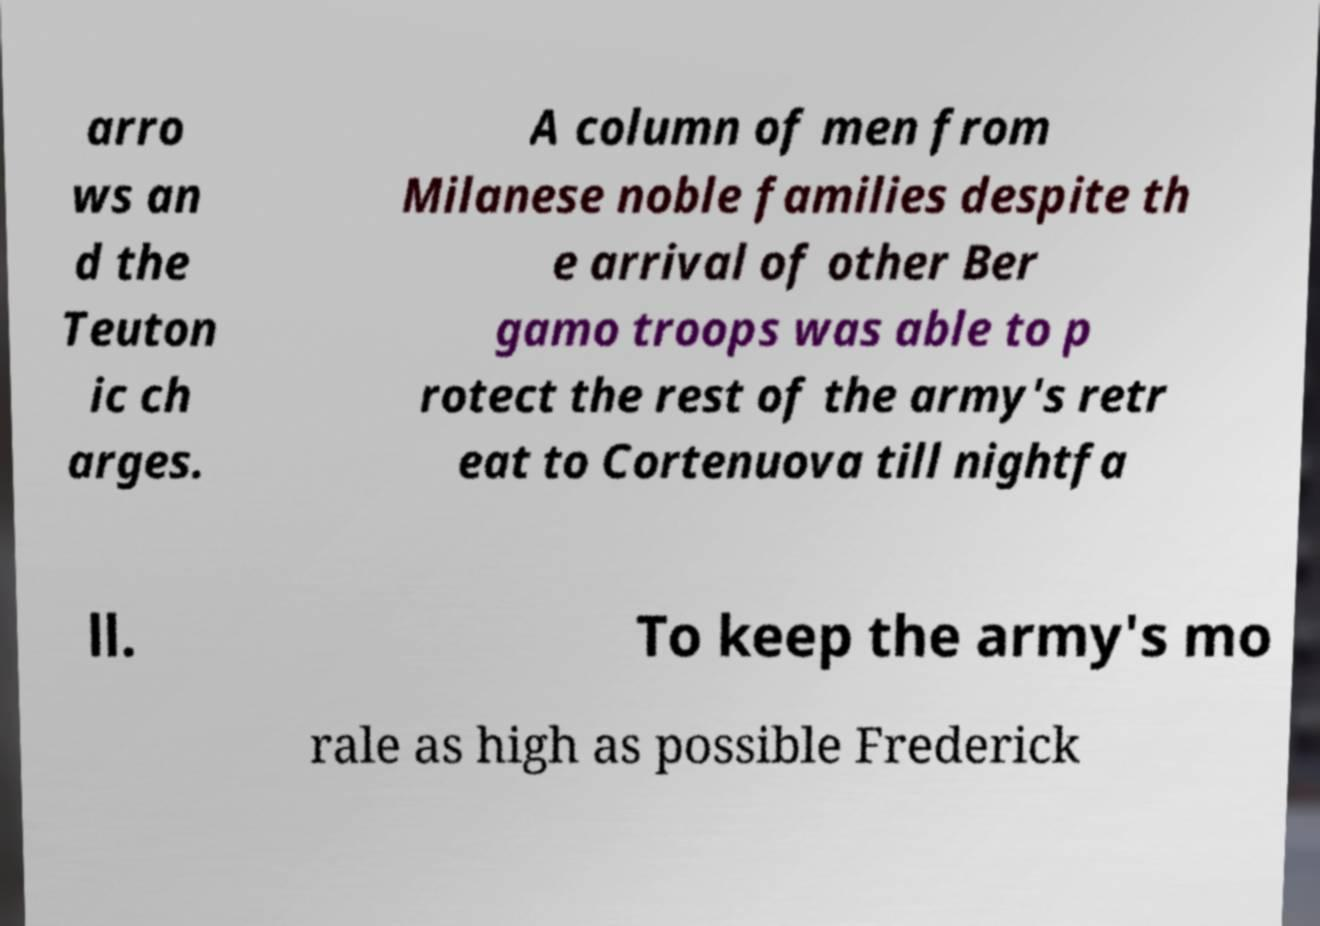For documentation purposes, I need the text within this image transcribed. Could you provide that? arro ws an d the Teuton ic ch arges. A column of men from Milanese noble families despite th e arrival of other Ber gamo troops was able to p rotect the rest of the army's retr eat to Cortenuova till nightfa ll. To keep the army's mo rale as high as possible Frederick 